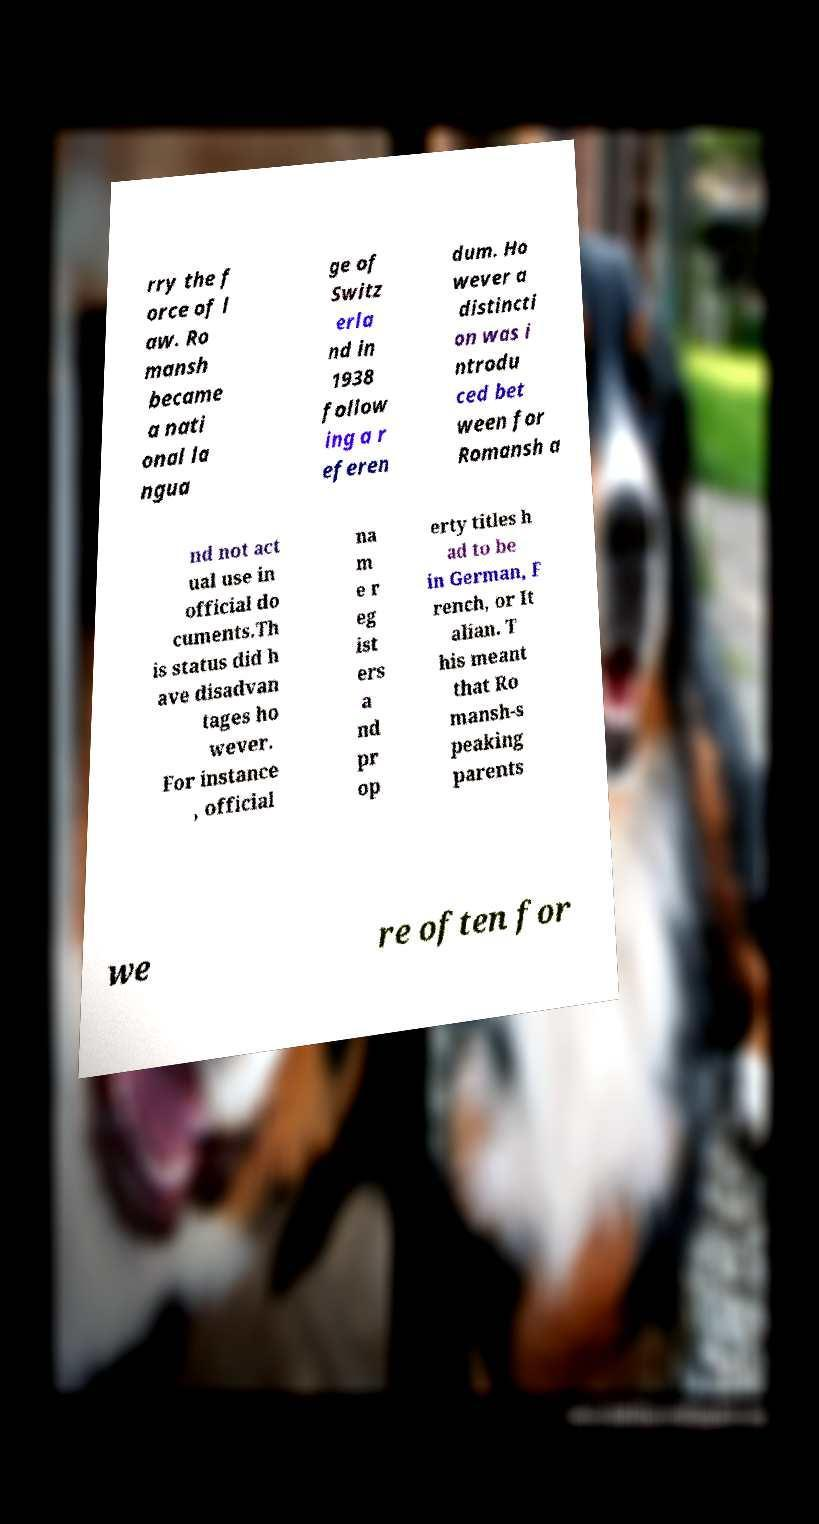For documentation purposes, I need the text within this image transcribed. Could you provide that? rry the f orce of l aw. Ro mansh became a nati onal la ngua ge of Switz erla nd in 1938 follow ing a r eferen dum. Ho wever a distincti on was i ntrodu ced bet ween for Romansh a nd not act ual use in official do cuments.Th is status did h ave disadvan tages ho wever. For instance , official na m e r eg ist ers a nd pr op erty titles h ad to be in German, F rench, or It alian. T his meant that Ro mansh-s peaking parents we re often for 